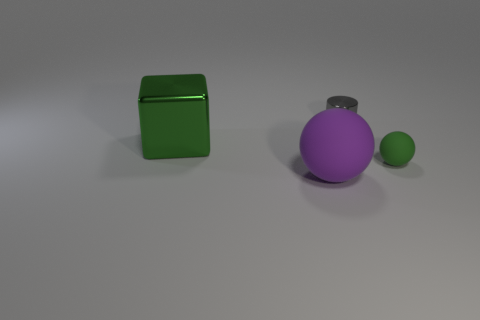What is the object that is both behind the green rubber ball and to the left of the small gray metallic cylinder made of?
Keep it short and to the point. Metal. How big is the metallic cylinder?
Give a very brief answer. Small. Does the shiny cube have the same color as the tiny object in front of the big green metallic object?
Make the answer very short. Yes. How many other objects are there of the same color as the block?
Provide a short and direct response. 1. There is a green object that is in front of the big metal object; is its size the same as the green object that is on the left side of the purple rubber object?
Keep it short and to the point. No. What color is the small thing that is to the right of the small gray shiny object?
Provide a succinct answer. Green. Are there fewer large green things that are in front of the large metal block than blue shiny objects?
Keep it short and to the point. No. Do the cylinder and the purple thing have the same material?
Your answer should be compact. No. The green matte object that is the same shape as the purple object is what size?
Offer a very short reply. Small. What number of things are tiny things to the left of the tiny green rubber thing or things in front of the shiny cylinder?
Ensure brevity in your answer.  4. 